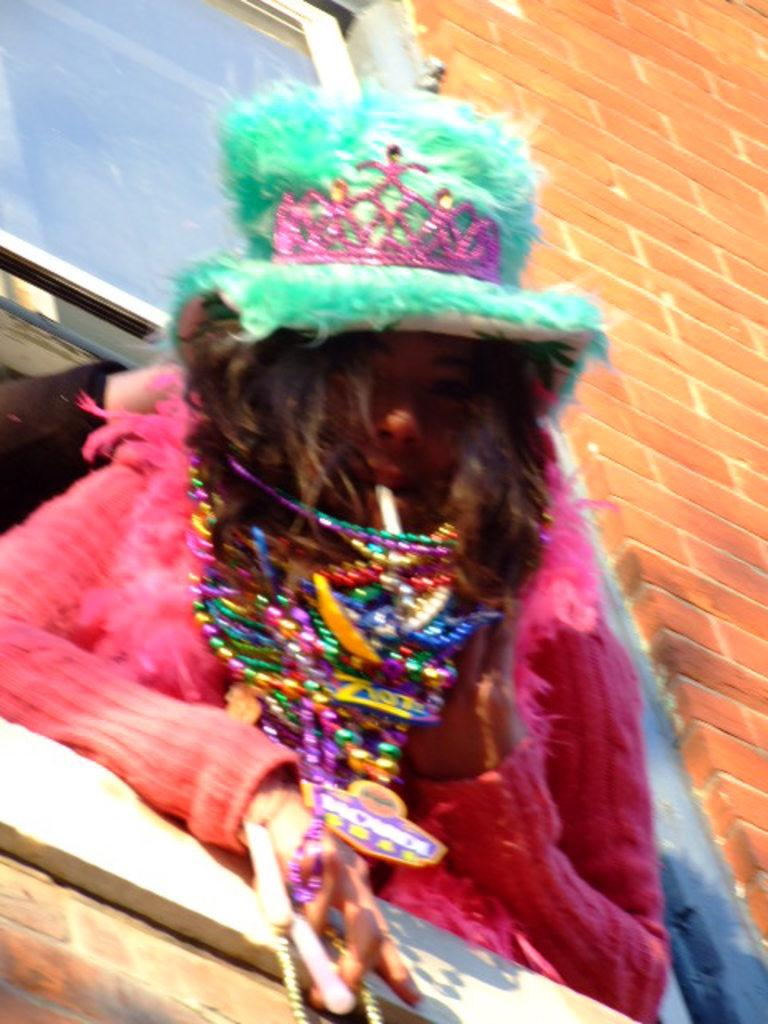Who is present in the image? There is a woman in the image. What is the woman wearing on her upper body? The woman is wearing a pink jacket. What type of headwear is the woman wearing? The woman is wearing a green hat. What can be seen in the background of the image? There is a window and a wall in the background of the image. What type of bed is visible in the image? There is no bed present in the image. 